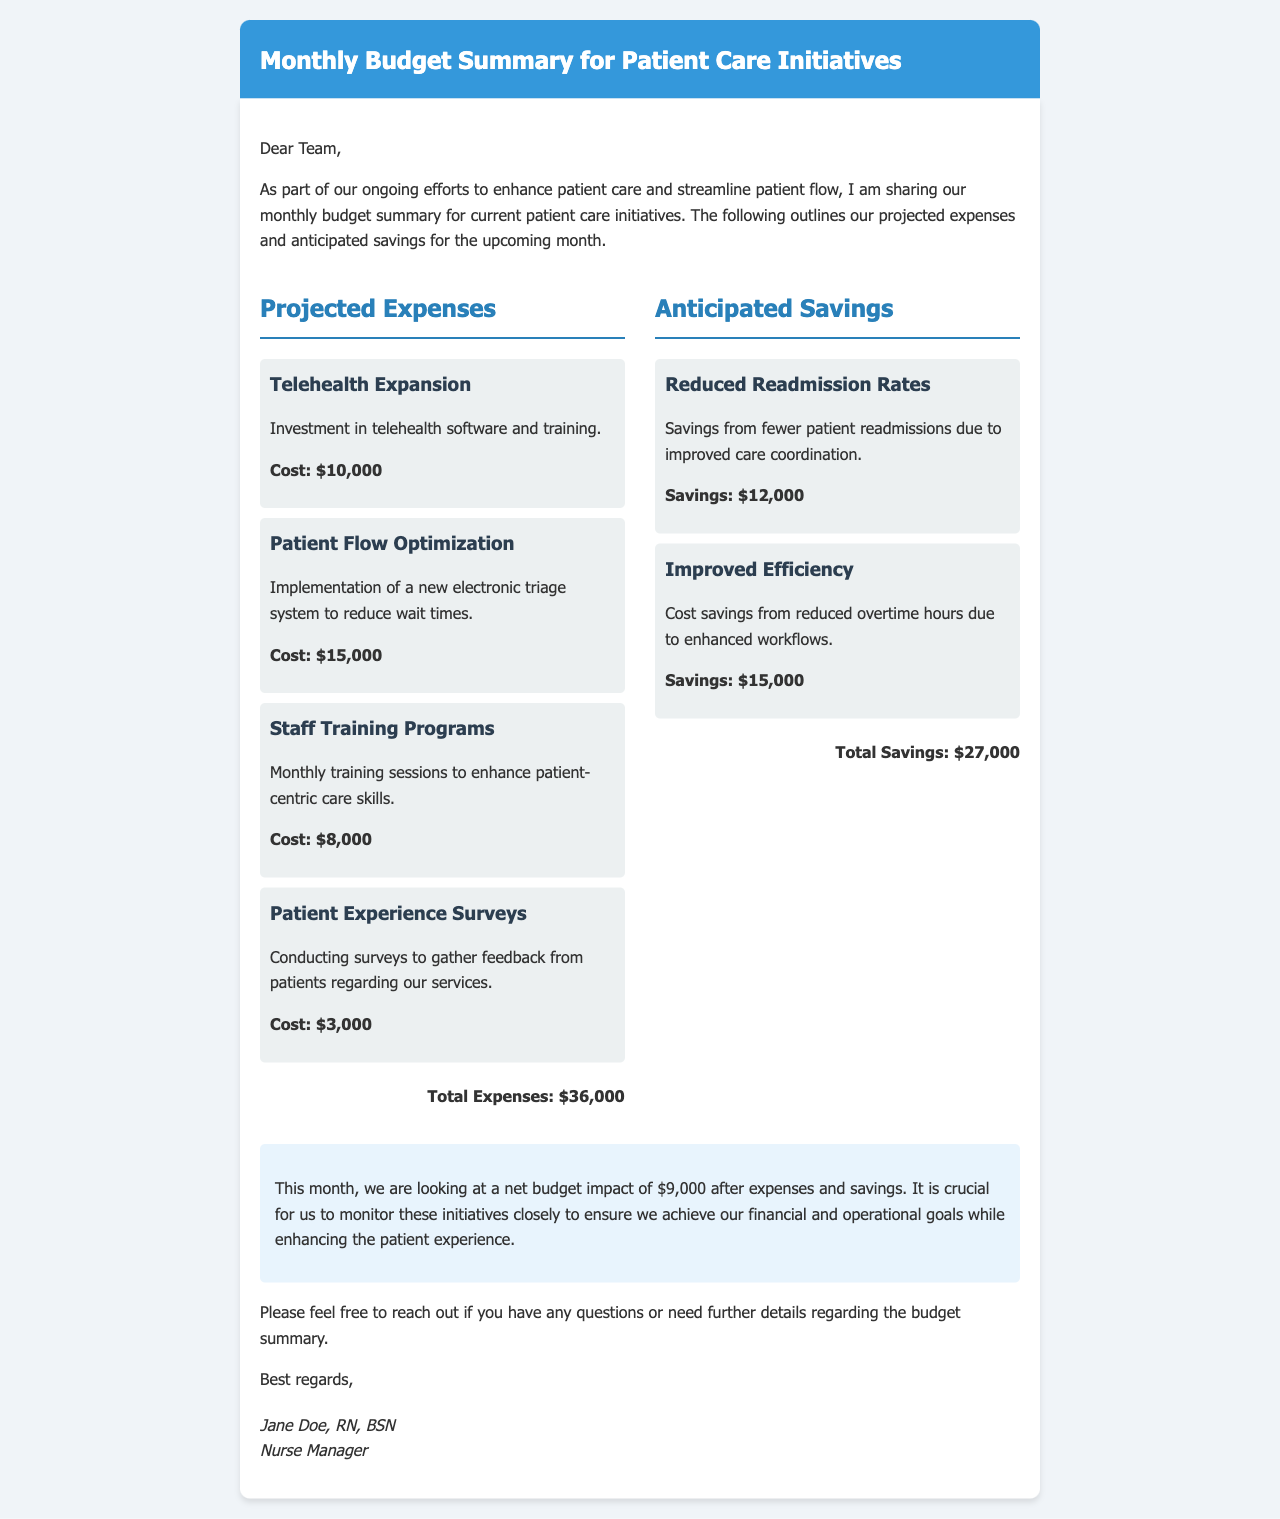what is the total cost for Telehealth Expansion? The cost for Telehealth Expansion is mentioned directly in the document as $10,000.
Answer: $10,000 what is the total projected expenses? The total projected expenses is the sum of all individual expenses listed in the document, which adds up to $36,000.
Answer: $36,000 what savings are anticipated from Improved Efficiency? The savings from Improved Efficiency are specifically stated in the document as $15,000.
Answer: $15,000 what is the net budget impact this month? The net budget impact is calculated by subtracting total savings from total expenses, resulting in a net impact of $9,000.
Answer: $9,000 how many initiatives are listed under Projected Expenses? The document lists four initiatives under Projected Expenses.
Answer: Four what is the title of the document? The title of the document is explicitly given at the top as "Monthly Budget Summary for Patient Care Initiatives."
Answer: Monthly Budget Summary for Patient Care Initiatives who is the sender of this document? The sender of the document is identified at the bottom as Jane Doe, RN, BSN, Nurse Manager.
Answer: Jane Doe, RN, BSN what is the cost of conducting Patient Experience Surveys? The cost of conducting Patient Experience Surveys is directly noted as $3,000 in the document.
Answer: $3,000 what is the cost associated with Staff Training Programs? The cost associated with Staff Training Programs is clearly stated as $8,000.
Answer: $8,000 